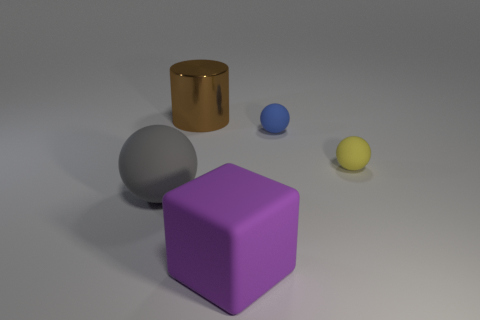Subtract all small blue balls. How many balls are left? 2 Add 1 large gray matte objects. How many objects exist? 6 Subtract all cylinders. How many objects are left? 4 Subtract all red spheres. Subtract all brown cylinders. How many spheres are left? 3 Subtract all large shiny cylinders. Subtract all large spheres. How many objects are left? 3 Add 3 big rubber blocks. How many big rubber blocks are left? 4 Add 4 tiny yellow rubber spheres. How many tiny yellow rubber spheres exist? 5 Subtract 1 purple cubes. How many objects are left? 4 